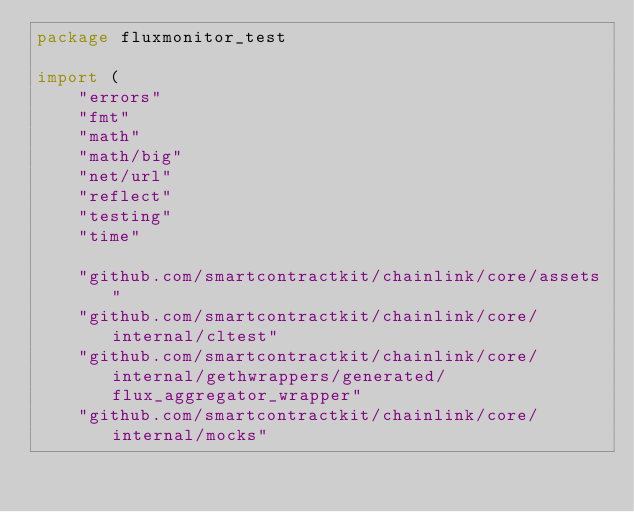Convert code to text. <code><loc_0><loc_0><loc_500><loc_500><_Go_>package fluxmonitor_test

import (
	"errors"
	"fmt"
	"math"
	"math/big"
	"net/url"
	"reflect"
	"testing"
	"time"

	"github.com/smartcontractkit/chainlink/core/assets"
	"github.com/smartcontractkit/chainlink/core/internal/cltest"
	"github.com/smartcontractkit/chainlink/core/internal/gethwrappers/generated/flux_aggregator_wrapper"
	"github.com/smartcontractkit/chainlink/core/internal/mocks"</code> 